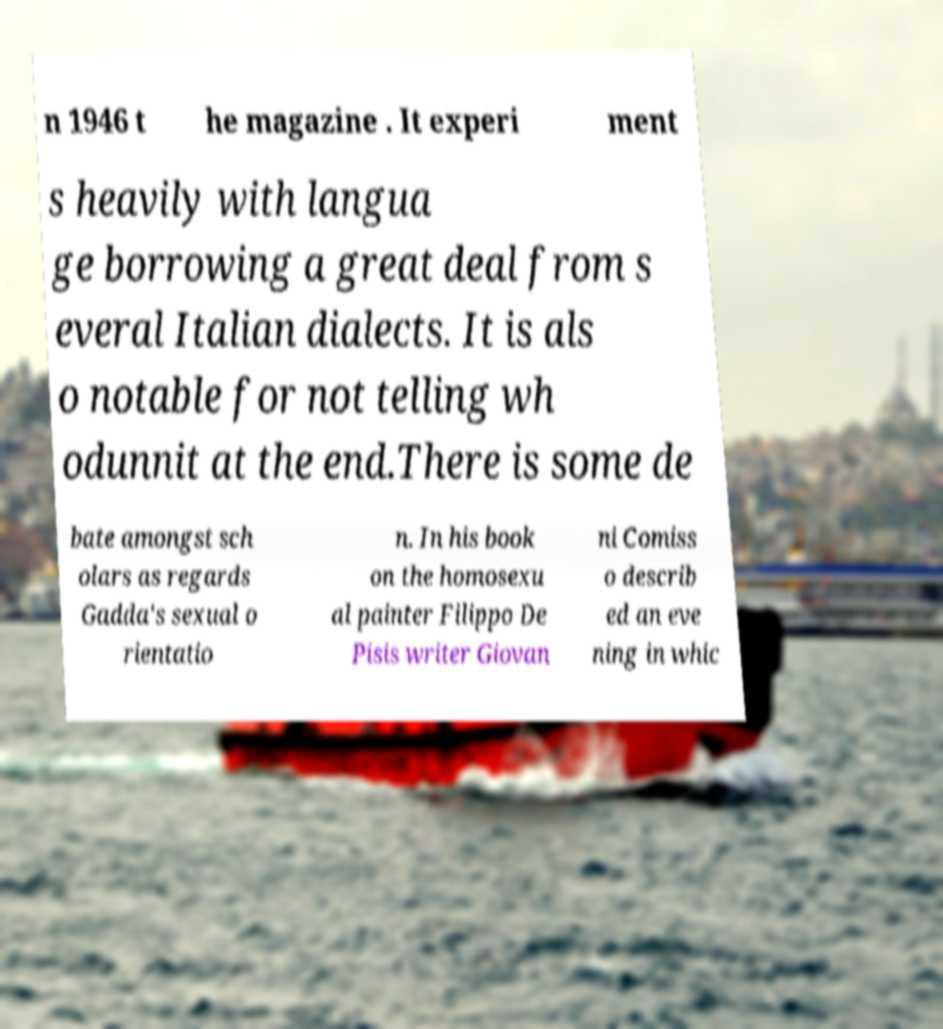Could you extract and type out the text from this image? n 1946 t he magazine . It experi ment s heavily with langua ge borrowing a great deal from s everal Italian dialects. It is als o notable for not telling wh odunnit at the end.There is some de bate amongst sch olars as regards Gadda's sexual o rientatio n. In his book on the homosexu al painter Filippo De Pisis writer Giovan ni Comiss o describ ed an eve ning in whic 